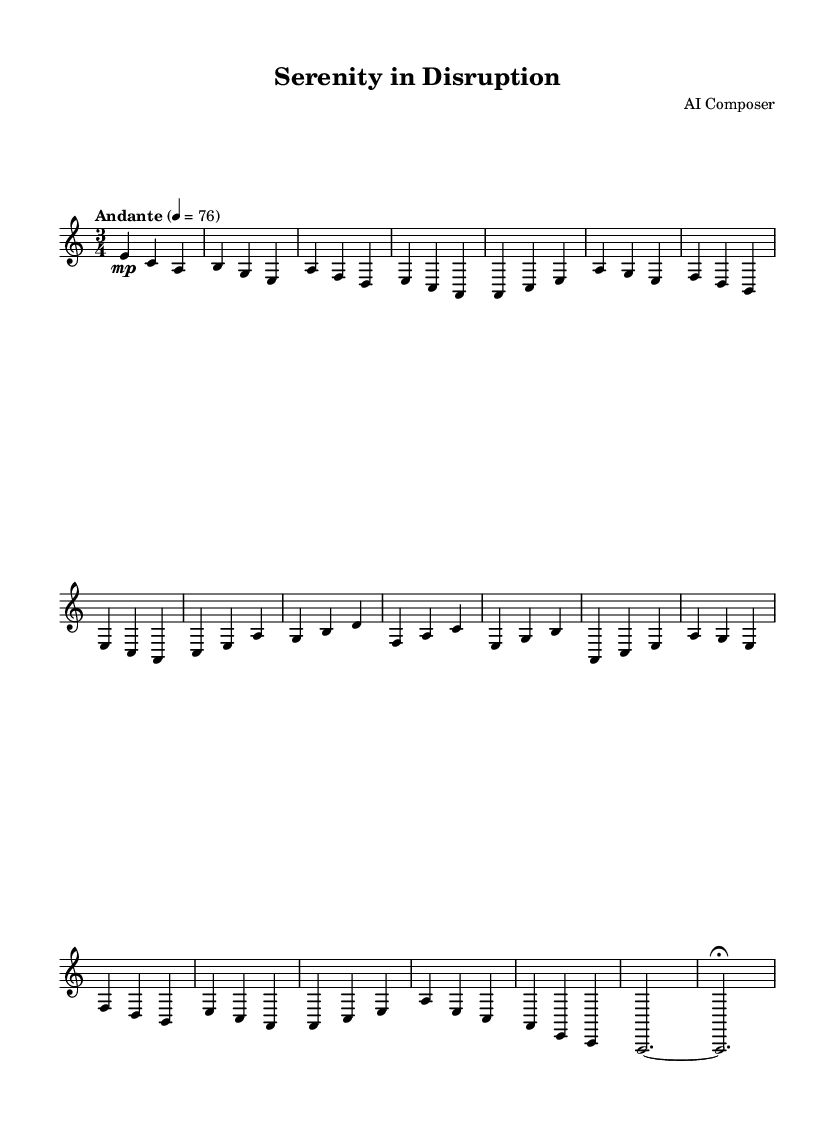What is the key signature of this music? The key signature is A minor, which has no sharps and consists of the notes A, B, C, D, E, F, and G.
Answer: A minor What is the time signature of this piece? The time signature is 3/4, indicating that each measure (bar) contains three beats, where the quarter note receives one beat.
Answer: 3/4 What is the tempo marking of the piece? The tempo marking is "Andante," which generally indicates a moderately slow tempo, typically around 76 beats per minute.
Answer: Andante How many sections are in the piece? There are three main sections labeled A, B, and A', with an introduction and a coda, totaling five sections overall.
Answer: Five What is the dynamic marking at the beginning? The dynamic marking is "mp," which stands for "mezzo-piano," indicating to play moderately soft at the start.
Answer: mp Which instrument is specified in the score for performance? The specified instrument is an "acoustic guitar (nylon)," indicating that this composition is intended for nylon-string guitar.
Answer: Acoustic guitar (nylon) What are the last two notes of the piece? The last two notes are A sustained to a fermata, suggesting to hold the last note longer than its usual duration for dramatic effect.
Answer: A, A 